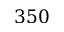Convert formula to latex. <formula><loc_0><loc_0><loc_500><loc_500>3 5 0</formula> 